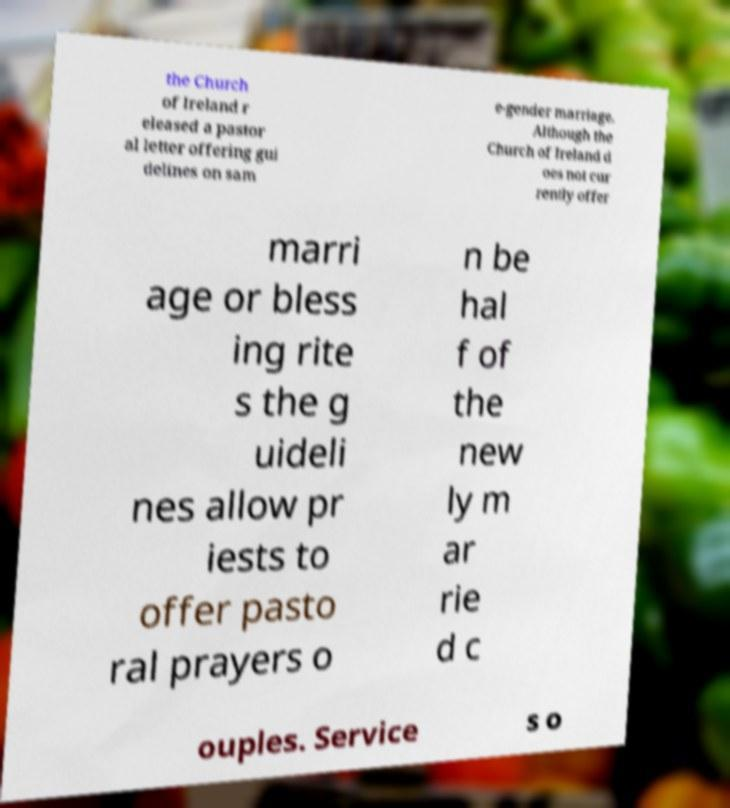Could you extract and type out the text from this image? the Church of Ireland r eleased a pastor al letter offering gui delines on sam e-gender marriage. Although the Church of Ireland d oes not cur rently offer marri age or bless ing rite s the g uideli nes allow pr iests to offer pasto ral prayers o n be hal f of the new ly m ar rie d c ouples. Service s o 